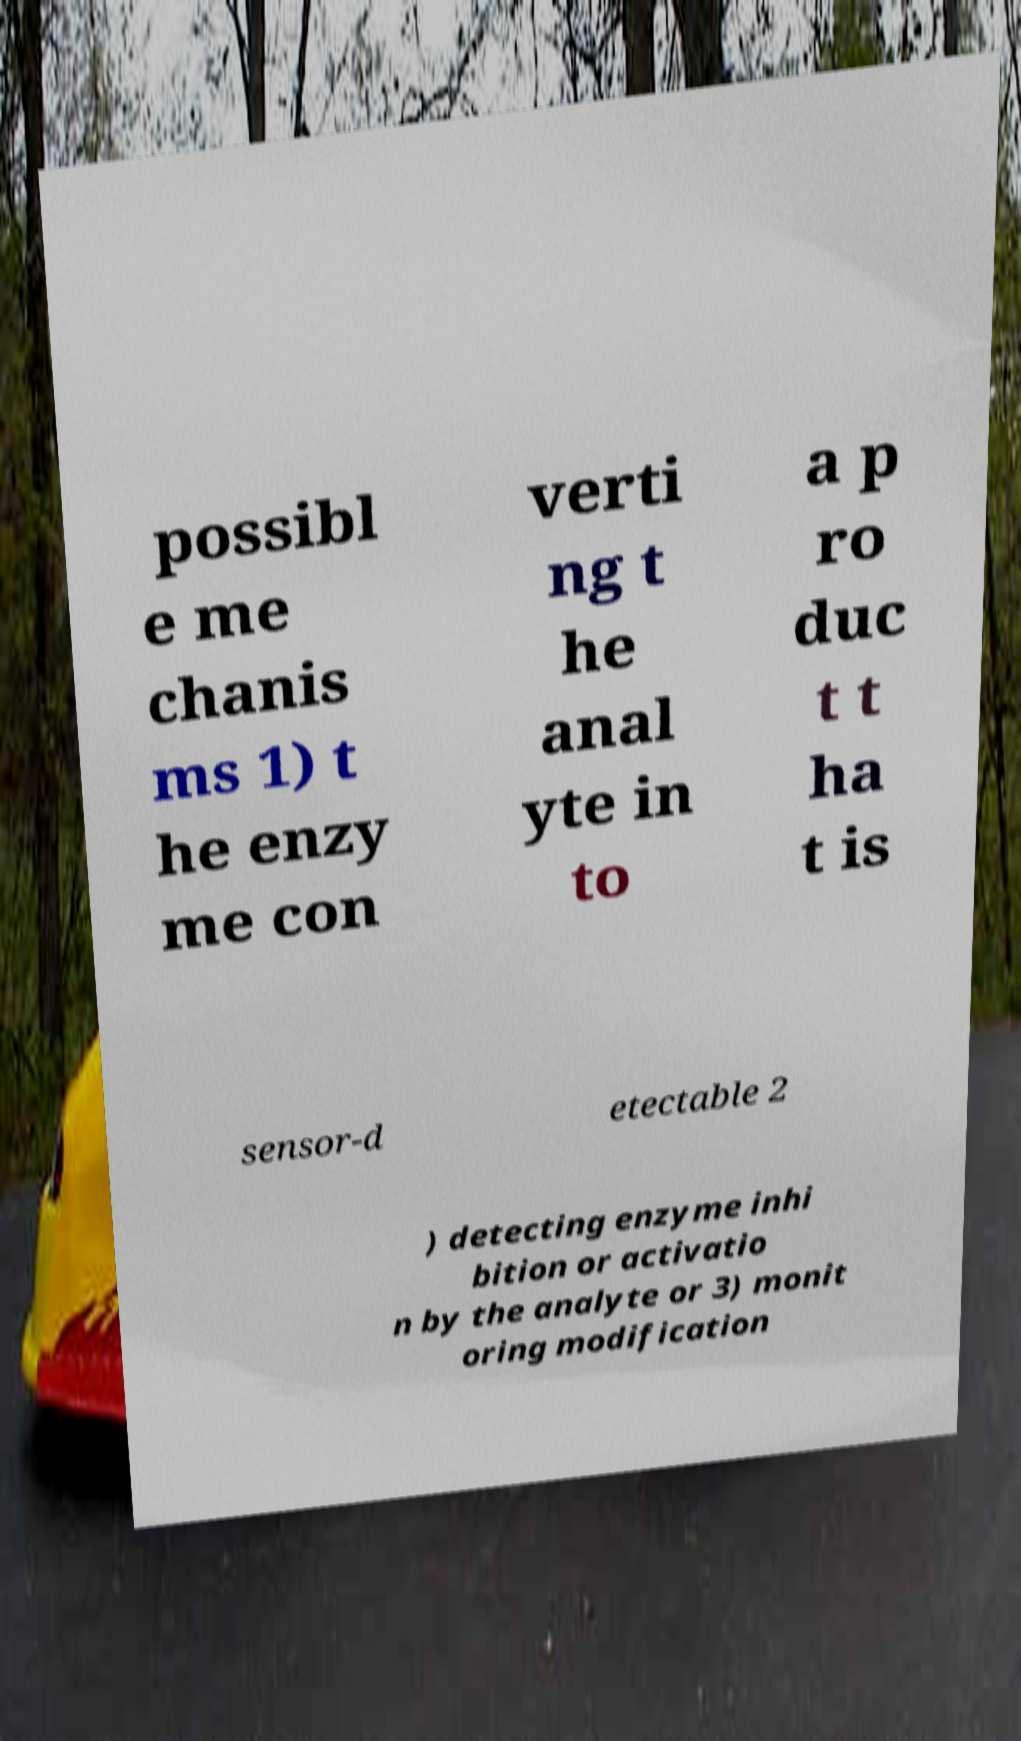For documentation purposes, I need the text within this image transcribed. Could you provide that? possibl e me chanis ms 1) t he enzy me con verti ng t he anal yte in to a p ro duc t t ha t is sensor-d etectable 2 ) detecting enzyme inhi bition or activatio n by the analyte or 3) monit oring modification 